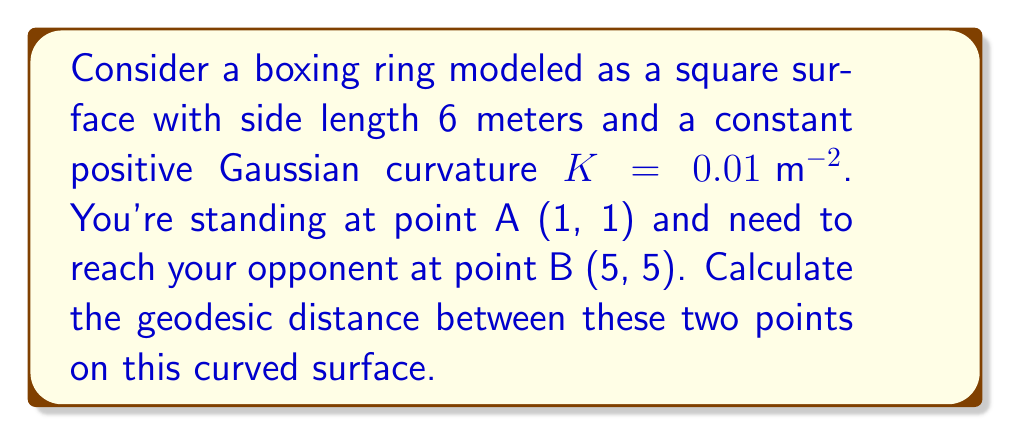What is the answer to this math problem? To solve this problem, we'll follow these steps:

1) First, recall that for a surface with constant positive Gaussian curvature $K$, we can model it as a sphere with radius $R = \frac{1}{\sqrt{K}}$.

2) Calculate the radius of our equivalent sphere:
   $R = \frac{1}{\sqrt{0.01}} = 10 \text{ m}$

3) Now, we need to map our square boxing ring onto this sphere. The side length of our ring is 6 m, so it covers an arc length of $\frac{6}{10} = 0.6$ radians on the sphere.

4) Convert the given coordinates to spherical coordinates:
   A (1, 1) → $(\frac{1}{6} \cdot 0.6, \frac{1}{6} \cdot 0.6) = (0.1, 0.1)$ radians
   B (5, 5) → $(\frac{5}{6} \cdot 0.6, \frac{5}{6} \cdot 0.6) = (0.5, 0.5)$ radians

5) Use the spherical distance formula to calculate the angle $\theta$ between these points:
   $$\cos(\theta) = \sin(\phi_1)\sin(\phi_2) + \cos(\phi_1)\cos(\phi_2)\cos(\Delta \lambda)$$
   where $\phi_1 = 0.1$, $\phi_2 = 0.5$, and $\Delta \lambda = 0.5 - 0.1 = 0.4$

6) Plug in the values:
   $$\cos(\theta) = \sin(0.1)\sin(0.5) + \cos(0.1)\cos(0.5)\cos(0.4)$$
   $$\cos(\theta) \approx 0.9396$$

7) Solve for $\theta$:
   $$\theta = \arccos(0.9396) \approx 0.3491 \text{ radians}$$

8) Finally, calculate the geodesic distance:
   $$d = R\theta = 10 \cdot 0.3491 \approx 3.491 \text{ m}$$
Answer: $3.491 \text{ m}$ 